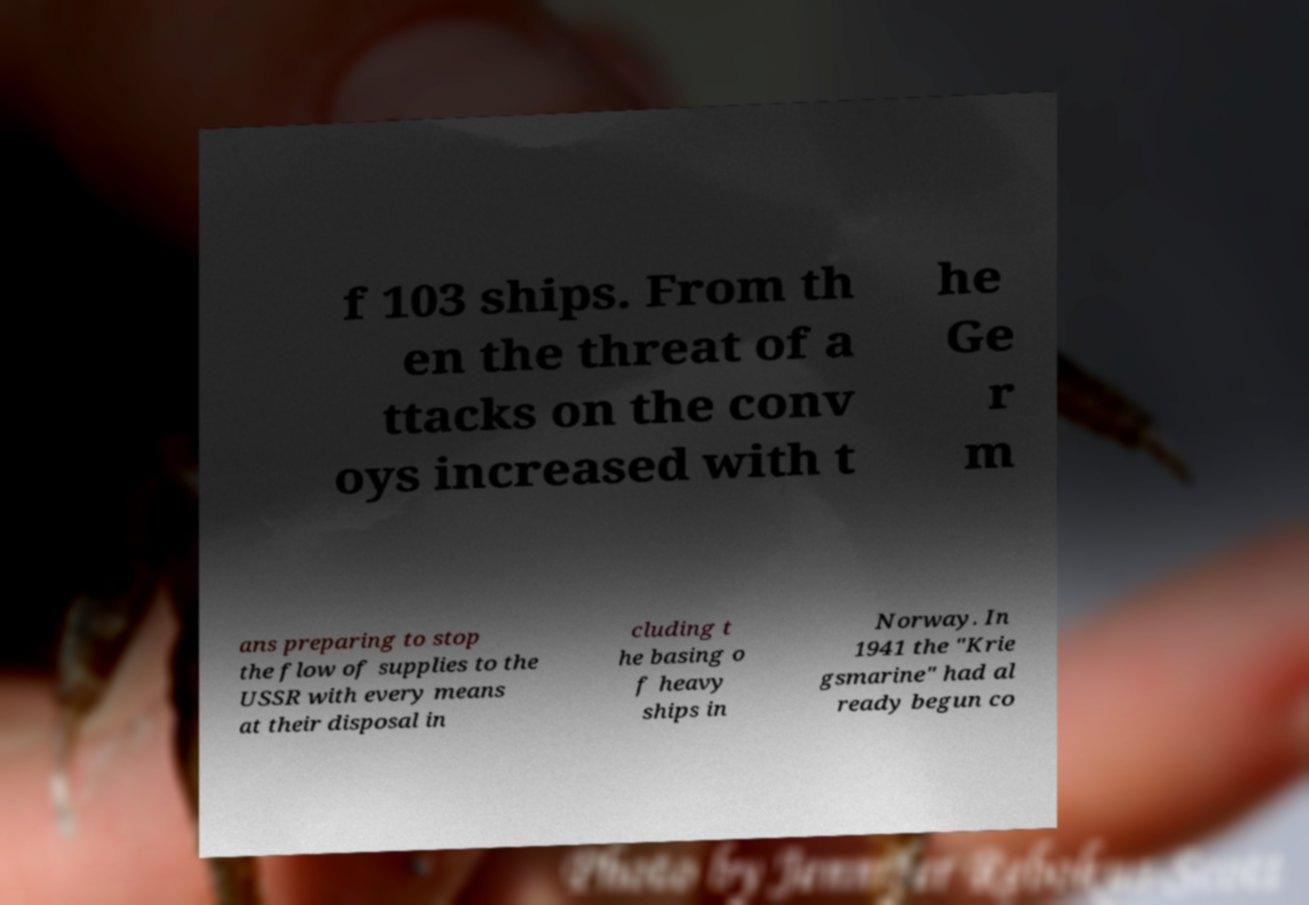Can you read and provide the text displayed in the image?This photo seems to have some interesting text. Can you extract and type it out for me? f 103 ships. From th en the threat of a ttacks on the conv oys increased with t he Ge r m ans preparing to stop the flow of supplies to the USSR with every means at their disposal in cluding t he basing o f heavy ships in Norway. In 1941 the "Krie gsmarine" had al ready begun co 